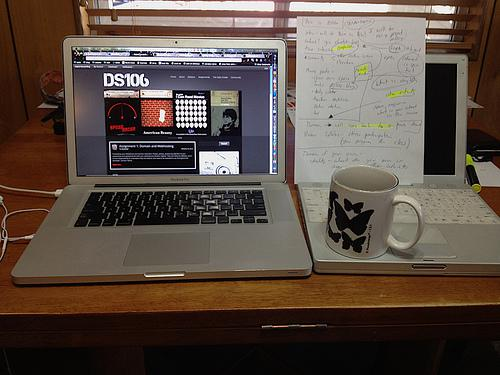Question: what is on the mug?
Choices:
A. Hearts.
B. Stars.
C. Shapes.
D. Butterflies.
Answer with the letter. Answer: D Question: what is on the table?
Choices:
A. Glasses.
B. Cups.
C. Laptops.
D. Silverware.
Answer with the letter. Answer: C Question: how many laptops are there?
Choices:
A. One.
B. Three.
C. Five.
D. Two.
Answer with the letter. Answer: D Question: what is the yellow marker?
Choices:
A. Coloring.
B. Highlighter.
C. Art tool.
D. Art.
Answer with the letter. Answer: B Question: what is covering the window?
Choices:
A. Drapes.
B. Curtains.
C. Shutters.
D. Blinds.
Answer with the letter. Answer: D Question: where is this work space?
Choices:
A. In an office.
B. In a coffee shop.
C. In a home.
D. Outside.
Answer with the letter. Answer: C Question: what site are they on?
Choices:
A. A worksite.
B. DS106.
C. A playground.
D. A park.
Answer with the letter. Answer: B 